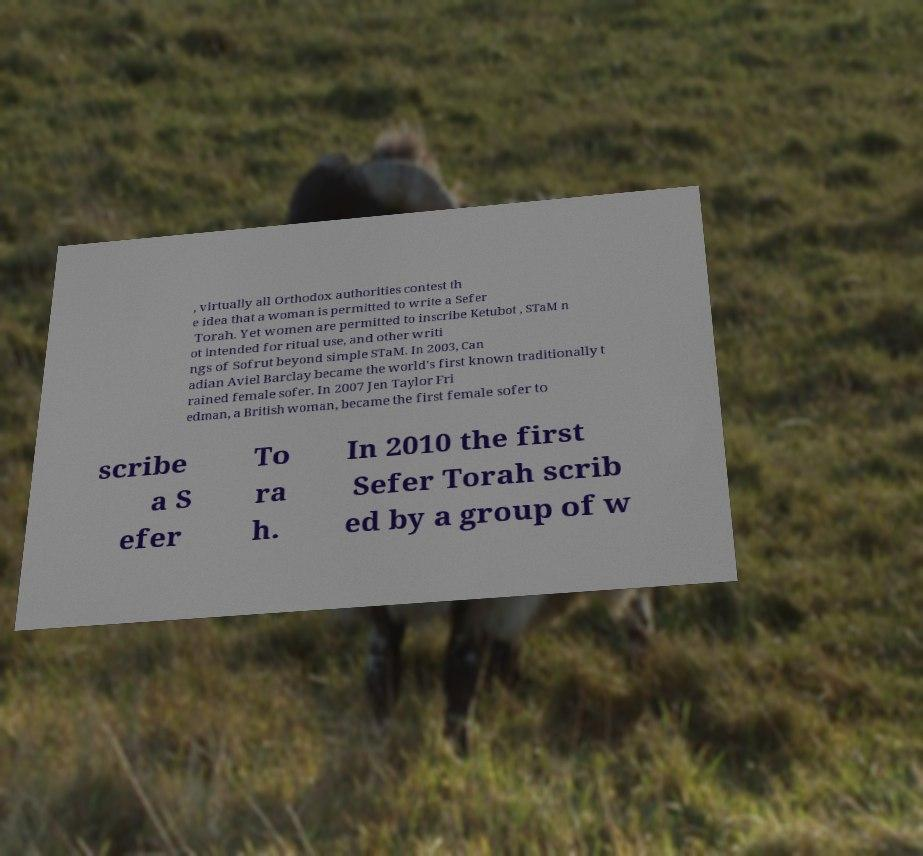For documentation purposes, I need the text within this image transcribed. Could you provide that? , virtually all Orthodox authorities contest th e idea that a woman is permitted to write a Sefer Torah. Yet women are permitted to inscribe Ketubot , STaM n ot intended for ritual use, and other writi ngs of Sofrut beyond simple STaM. In 2003, Can adian Aviel Barclay became the world's first known traditionally t rained female sofer. In 2007 Jen Taylor Fri edman, a British woman, became the first female sofer to scribe a S efer To ra h. In 2010 the first Sefer Torah scrib ed by a group of w 